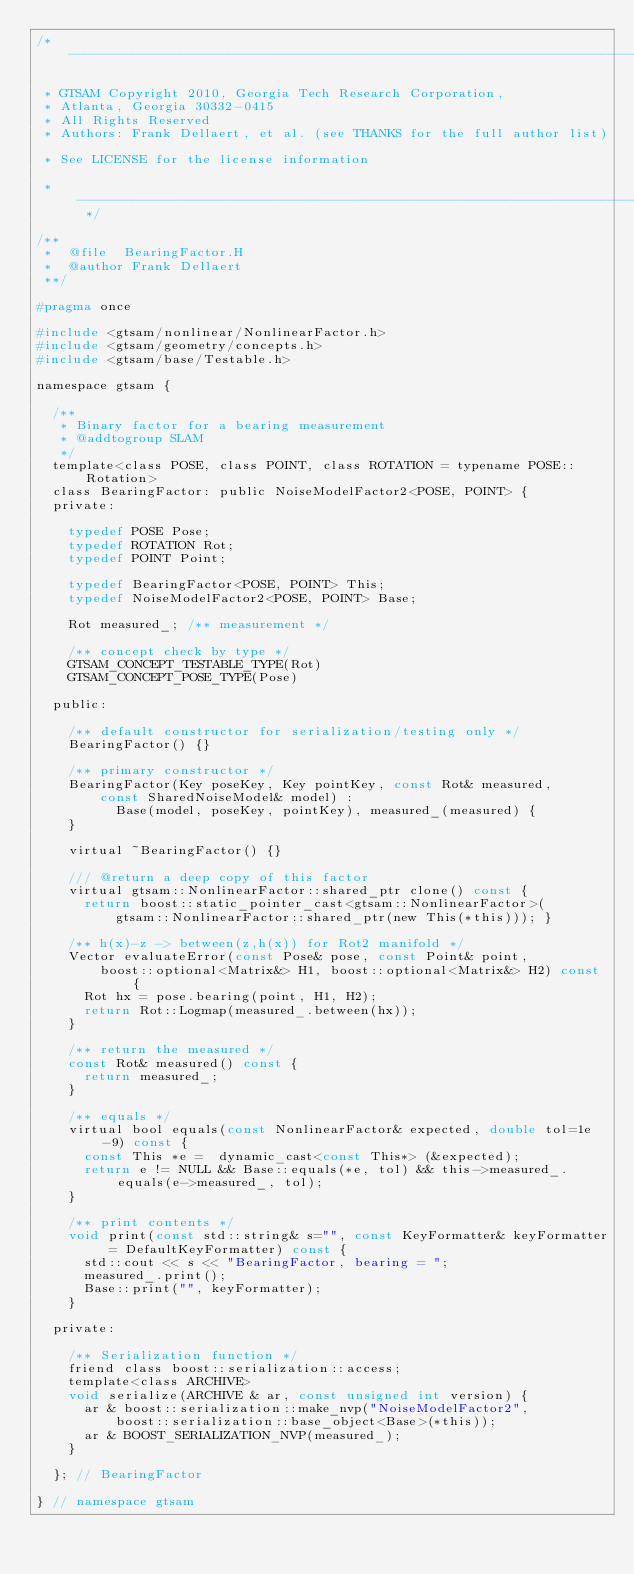Convert code to text. <code><loc_0><loc_0><loc_500><loc_500><_C_>/* ----------------------------------------------------------------------------

 * GTSAM Copyright 2010, Georgia Tech Research Corporation, 
 * Atlanta, Georgia 30332-0415
 * All Rights Reserved
 * Authors: Frank Dellaert, et al. (see THANKS for the full author list)

 * See LICENSE for the license information

 * -------------------------------------------------------------------------- */

/**
 *  @file  BearingFactor.H
 *  @author Frank Dellaert
 **/

#pragma once

#include <gtsam/nonlinear/NonlinearFactor.h>
#include <gtsam/geometry/concepts.h>
#include <gtsam/base/Testable.h>

namespace gtsam {

  /**
   * Binary factor for a bearing measurement
   * @addtogroup SLAM
   */
  template<class POSE, class POINT, class ROTATION = typename POSE::Rotation>
  class BearingFactor: public NoiseModelFactor2<POSE, POINT> {
  private:

    typedef POSE Pose;
    typedef ROTATION Rot;
    typedef POINT Point;

    typedef BearingFactor<POSE, POINT> This;
    typedef NoiseModelFactor2<POSE, POINT> Base;

    Rot measured_; /** measurement */

    /** concept check by type */
    GTSAM_CONCEPT_TESTABLE_TYPE(Rot)
    GTSAM_CONCEPT_POSE_TYPE(Pose)

  public:

    /** default constructor for serialization/testing only */
    BearingFactor() {}

    /** primary constructor */
    BearingFactor(Key poseKey, Key pointKey, const Rot& measured,
        const SharedNoiseModel& model) :
          Base(model, poseKey, pointKey), measured_(measured) {
    }

    virtual ~BearingFactor() {}

    /// @return a deep copy of this factor
    virtual gtsam::NonlinearFactor::shared_ptr clone() const {
      return boost::static_pointer_cast<gtsam::NonlinearFactor>(
          gtsam::NonlinearFactor::shared_ptr(new This(*this))); }

    /** h(x)-z -> between(z,h(x)) for Rot2 manifold */
    Vector evaluateError(const Pose& pose, const Point& point,
        boost::optional<Matrix&> H1, boost::optional<Matrix&> H2) const {
      Rot hx = pose.bearing(point, H1, H2);
      return Rot::Logmap(measured_.between(hx));
    }

    /** return the measured */
    const Rot& measured() const {
      return measured_;
    }

    /** equals */
    virtual bool equals(const NonlinearFactor& expected, double tol=1e-9) const {
      const This *e =  dynamic_cast<const This*> (&expected);
      return e != NULL && Base::equals(*e, tol) && this->measured_.equals(e->measured_, tol);
    }

    /** print contents */
    void print(const std::string& s="", const KeyFormatter& keyFormatter = DefaultKeyFormatter) const {
      std::cout << s << "BearingFactor, bearing = ";
      measured_.print();
      Base::print("", keyFormatter);
    }

  private:

    /** Serialization function */
    friend class boost::serialization::access;
    template<class ARCHIVE>
    void serialize(ARCHIVE & ar, const unsigned int version) {
      ar & boost::serialization::make_nvp("NoiseModelFactor2",
          boost::serialization::base_object<Base>(*this));
      ar & BOOST_SERIALIZATION_NVP(measured_);
    }

  }; // BearingFactor

} // namespace gtsam
</code> 